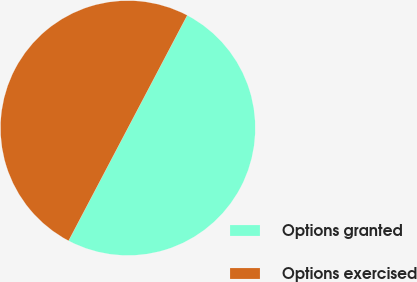Convert chart. <chart><loc_0><loc_0><loc_500><loc_500><pie_chart><fcel>Options granted<fcel>Options exercised<nl><fcel>50.0%<fcel>50.0%<nl></chart> 